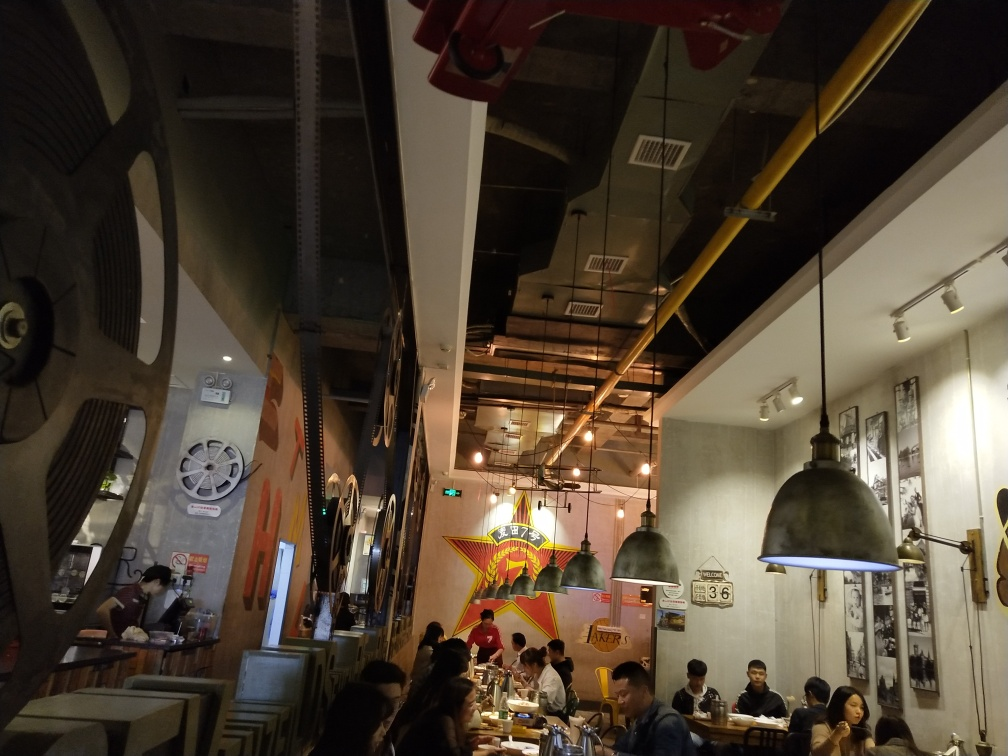What kind of meal or occasion do you think this place is suitable for? Given the relaxed and trendy atmosphere, this establishment seems suited for casual dining experiences such as friends gathering for dinner, informal business meetings, or individuals enjoying a leisurely meal. The decor suggests that it might also attract movie enthusiasts or those looking for a place with a unique thematic experience. 